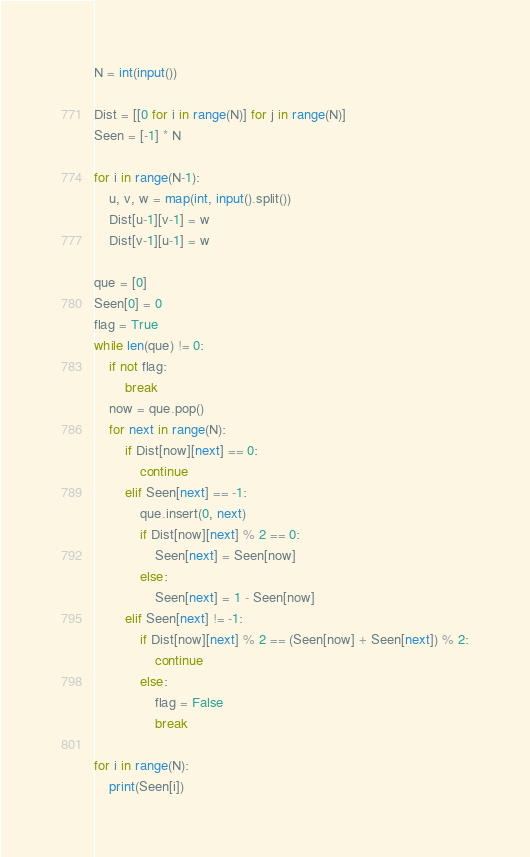<code> <loc_0><loc_0><loc_500><loc_500><_Python_>N = int(input())

Dist = [[0 for i in range(N)] for j in range(N)]
Seen = [-1] * N

for i in range(N-1):
    u, v, w = map(int, input().split())
    Dist[u-1][v-1] = w
    Dist[v-1][u-1] = w

que = [0]
Seen[0] = 0
flag = True
while len(que) != 0:
    if not flag:
        break
    now = que.pop()
    for next in range(N):
        if Dist[now][next] == 0:
            continue
        elif Seen[next] == -1:
            que.insert(0, next)
            if Dist[now][next] % 2 == 0:
                Seen[next] = Seen[now]
            else:
                Seen[next] = 1 - Seen[now]
        elif Seen[next] != -1:
            if Dist[now][next] % 2 == (Seen[now] + Seen[next]) % 2:
                continue
            else:
                flag = False
                break

for i in range(N):
    print(Seen[i])
</code> 